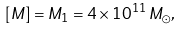Convert formula to latex. <formula><loc_0><loc_0><loc_500><loc_500>[ M ] = M _ { 1 } = 4 \times 1 0 ^ { 1 1 } \, { M _ { \odot } } , \\</formula> 